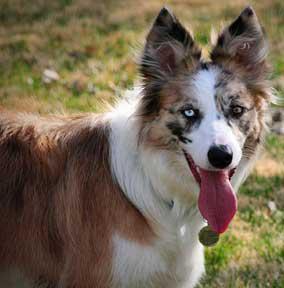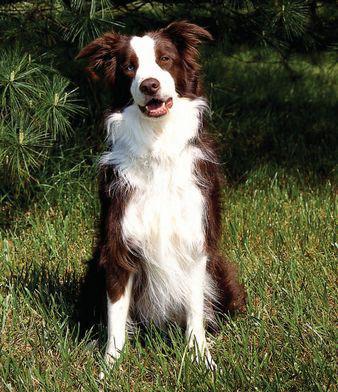The first image is the image on the left, the second image is the image on the right. Given the left and right images, does the statement "At least one dog has its mouth open." hold true? Answer yes or no. Yes. The first image is the image on the left, the second image is the image on the right. Examine the images to the left and right. Is the description "One dog is black with white on its legs and chest." accurate? Answer yes or no. Yes. 